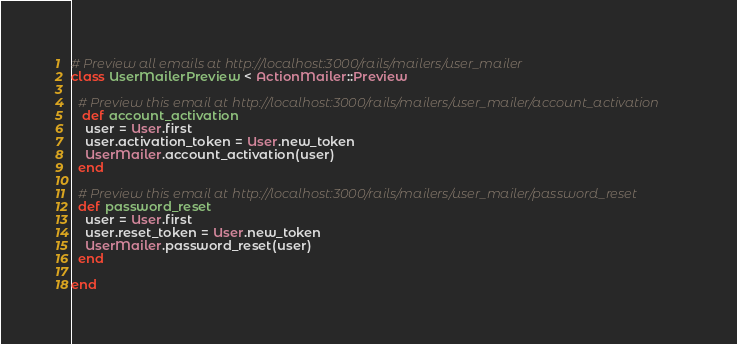<code> <loc_0><loc_0><loc_500><loc_500><_Ruby_># Preview all emails at http://localhost:3000/rails/mailers/user_mailer
class UserMailerPreview < ActionMailer::Preview

  # Preview this email at http://localhost:3000/rails/mailers/user_mailer/account_activation
   def account_activation
    user = User.first
    user.activation_token = User.new_token
    UserMailer.account_activation(user)
  end

  # Preview this email at http://localhost:3000/rails/mailers/user_mailer/password_reset
  def password_reset
    user = User.first
    user.reset_token = User.new_token
    UserMailer.password_reset(user)
  end

end
</code> 